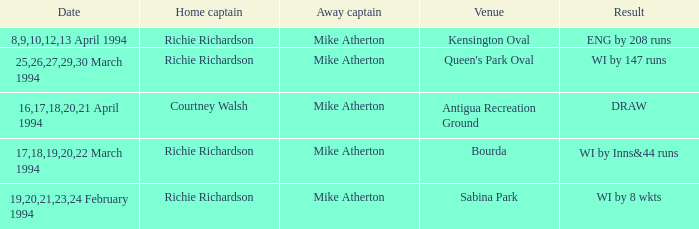Which Home Captain has Eng by 208 runs? Richie Richardson. 